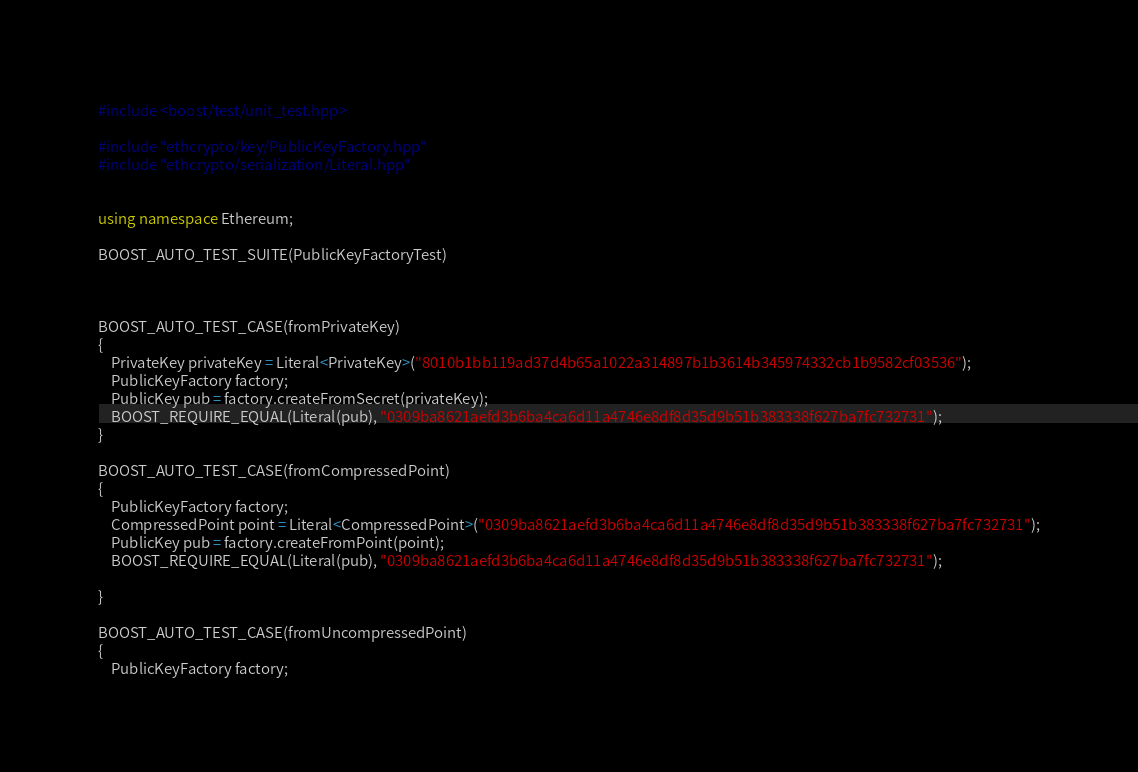<code> <loc_0><loc_0><loc_500><loc_500><_C++_>#include <boost/test/unit_test.hpp>

#include "ethcrypto/key/PublicKeyFactory.hpp"
#include "ethcrypto/serialization/Literal.hpp"


using namespace Ethereum;

BOOST_AUTO_TEST_SUITE(PublicKeyFactoryTest)



BOOST_AUTO_TEST_CASE(fromPrivateKey)
{
    PrivateKey privateKey = Literal<PrivateKey>("8010b1bb119ad37d4b65a1022a314897b1b3614b345974332cb1b9582cf03536");
    PublicKeyFactory factory;
    PublicKey pub = factory.createFromSecret(privateKey);
    BOOST_REQUIRE_EQUAL(Literal(pub), "0309ba8621aefd3b6ba4ca6d11a4746e8df8d35d9b51b383338f627ba7fc732731");
}

BOOST_AUTO_TEST_CASE(fromCompressedPoint)
{
    PublicKeyFactory factory;
    CompressedPoint point = Literal<CompressedPoint>("0309ba8621aefd3b6ba4ca6d11a4746e8df8d35d9b51b383338f627ba7fc732731");
    PublicKey pub = factory.createFromPoint(point);
    BOOST_REQUIRE_EQUAL(Literal(pub), "0309ba8621aefd3b6ba4ca6d11a4746e8df8d35d9b51b383338f627ba7fc732731");

}

BOOST_AUTO_TEST_CASE(fromUncompressedPoint)
{
    PublicKeyFactory factory;</code> 